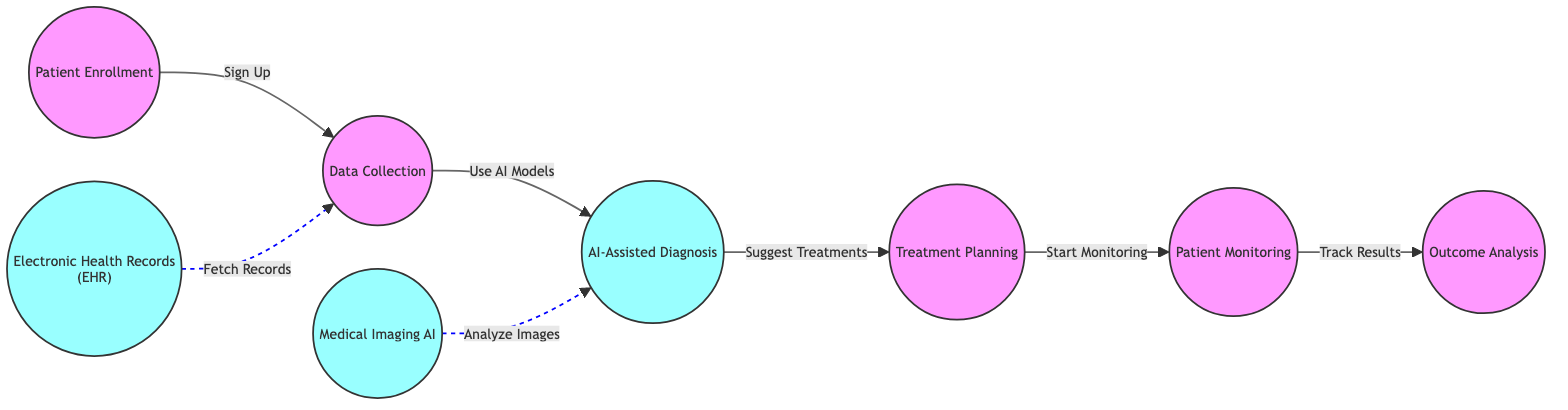What is the first step in the workflow? The first step in the workflow is Patient Enrollment, as indicated on the diagram, where it shows the starting point for the process.
Answer: Patient Enrollment How many AI nodes are present in the diagram? There are three AI nodes: AI-Assisted Diagnosis, Electronic Health Records (EHR), and Medical Imaging AI. Each of these nodes is specifically marked as an AI node in the diagram.
Answer: 3 What action is taken after Treatment Planning? After Treatment Planning, the next action taken is Start Monitoring, as shown by the arrow connecting these two nodes in the workflow.
Answer: Start Monitoring What type of relationship exists between Electronic Health Records and Data Collection? The relationship between Electronic Health Records and Data Collection is a dashed line indicating a fetch record action, meaning EHR will fetch records to aid in Data Collection without a direct path.
Answer: Fetch Records In which step does patient monitoring occur? Patient Monitoring occurs after Treatment Planning, as illustrated by the flow from Treatment Planning to Patient Monitoring in the sequence.
Answer: Patient Monitoring What does the AI-Assisted Diagnosis node provide to the Treatment Planning step? The AI-Assisted Diagnosis node suggests treatments to the Treatment Planning step, indicating that it plays a key role in informing next steps in patient care.
Answer: Suggest Treatments How does Medical Imaging AI contribute to the workflow? Medical Imaging AI analyzes images, which is a crucial step that supports the AI-Assisted Diagnosis for making informed decisions. This relationship is depicted with a dashed line in the diagram.
Answer: Analyze Images What is the final step in the workflow? The final step in the workflow is Outcome Analysis. It indicates the evaluation process after all prior steps have been completed, marked as the last node in the flowchart.
Answer: Outcome Analysis What connects Patient Monitoring to Outcome Analysis? The connection between Patient Monitoring and Outcome Analysis is represented by a solid arrow, indicating a direct progression from monitoring to analysis of results.
Answer: Track Results 